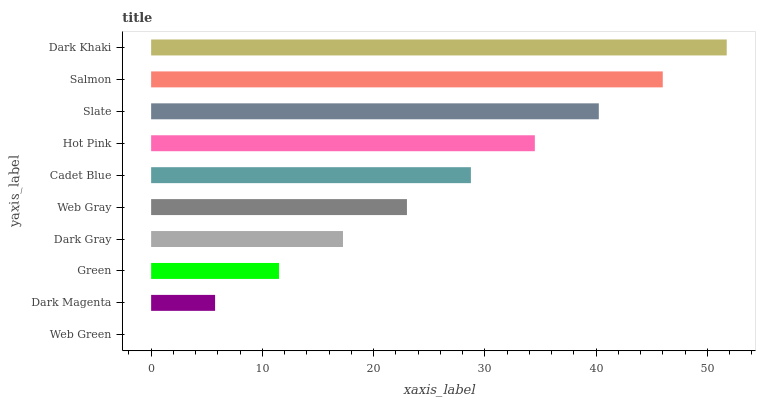Is Web Green the minimum?
Answer yes or no. Yes. Is Dark Khaki the maximum?
Answer yes or no. Yes. Is Dark Magenta the minimum?
Answer yes or no. No. Is Dark Magenta the maximum?
Answer yes or no. No. Is Dark Magenta greater than Web Green?
Answer yes or no. Yes. Is Web Green less than Dark Magenta?
Answer yes or no. Yes. Is Web Green greater than Dark Magenta?
Answer yes or no. No. Is Dark Magenta less than Web Green?
Answer yes or no. No. Is Cadet Blue the high median?
Answer yes or no. Yes. Is Web Gray the low median?
Answer yes or no. Yes. Is Dark Gray the high median?
Answer yes or no. No. Is Web Green the low median?
Answer yes or no. No. 